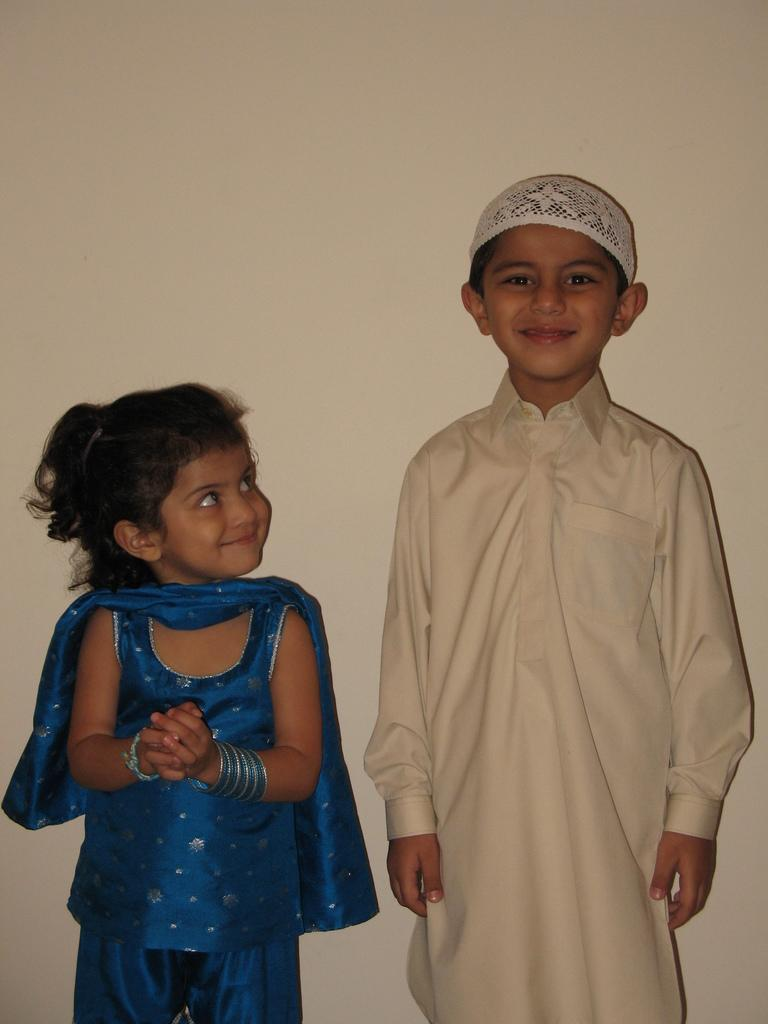How many kids are in the image? There are two kids in the image. Can you describe the appearance of the boy? The boy is wearing a tall shirt and a mask to his head. What is the girl wearing? The girl is wearing a blue dress. What is the girl doing in the image? The girl is looking at the boy and smiling. What type of wax is being used by the kids to play basketball in the image? There is no mention of wax or basketball in the image; it features two kids, one of whom is wearing a tall shirt and a mask, while the other is wearing a blue dress and smiling at him. 